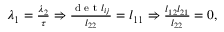<formula> <loc_0><loc_0><loc_500><loc_500>\begin{array} { r } { \lambda _ { 1 } = \frac { \lambda _ { 2 } } { \tau } \Rightarrow \frac { d e t l _ { i j } } { l _ { 2 2 } } = l _ { 1 1 } \Rightarrow \frac { l _ { 1 2 } l _ { 2 1 } } { l _ { 2 2 } } = 0 , } \end{array}</formula> 